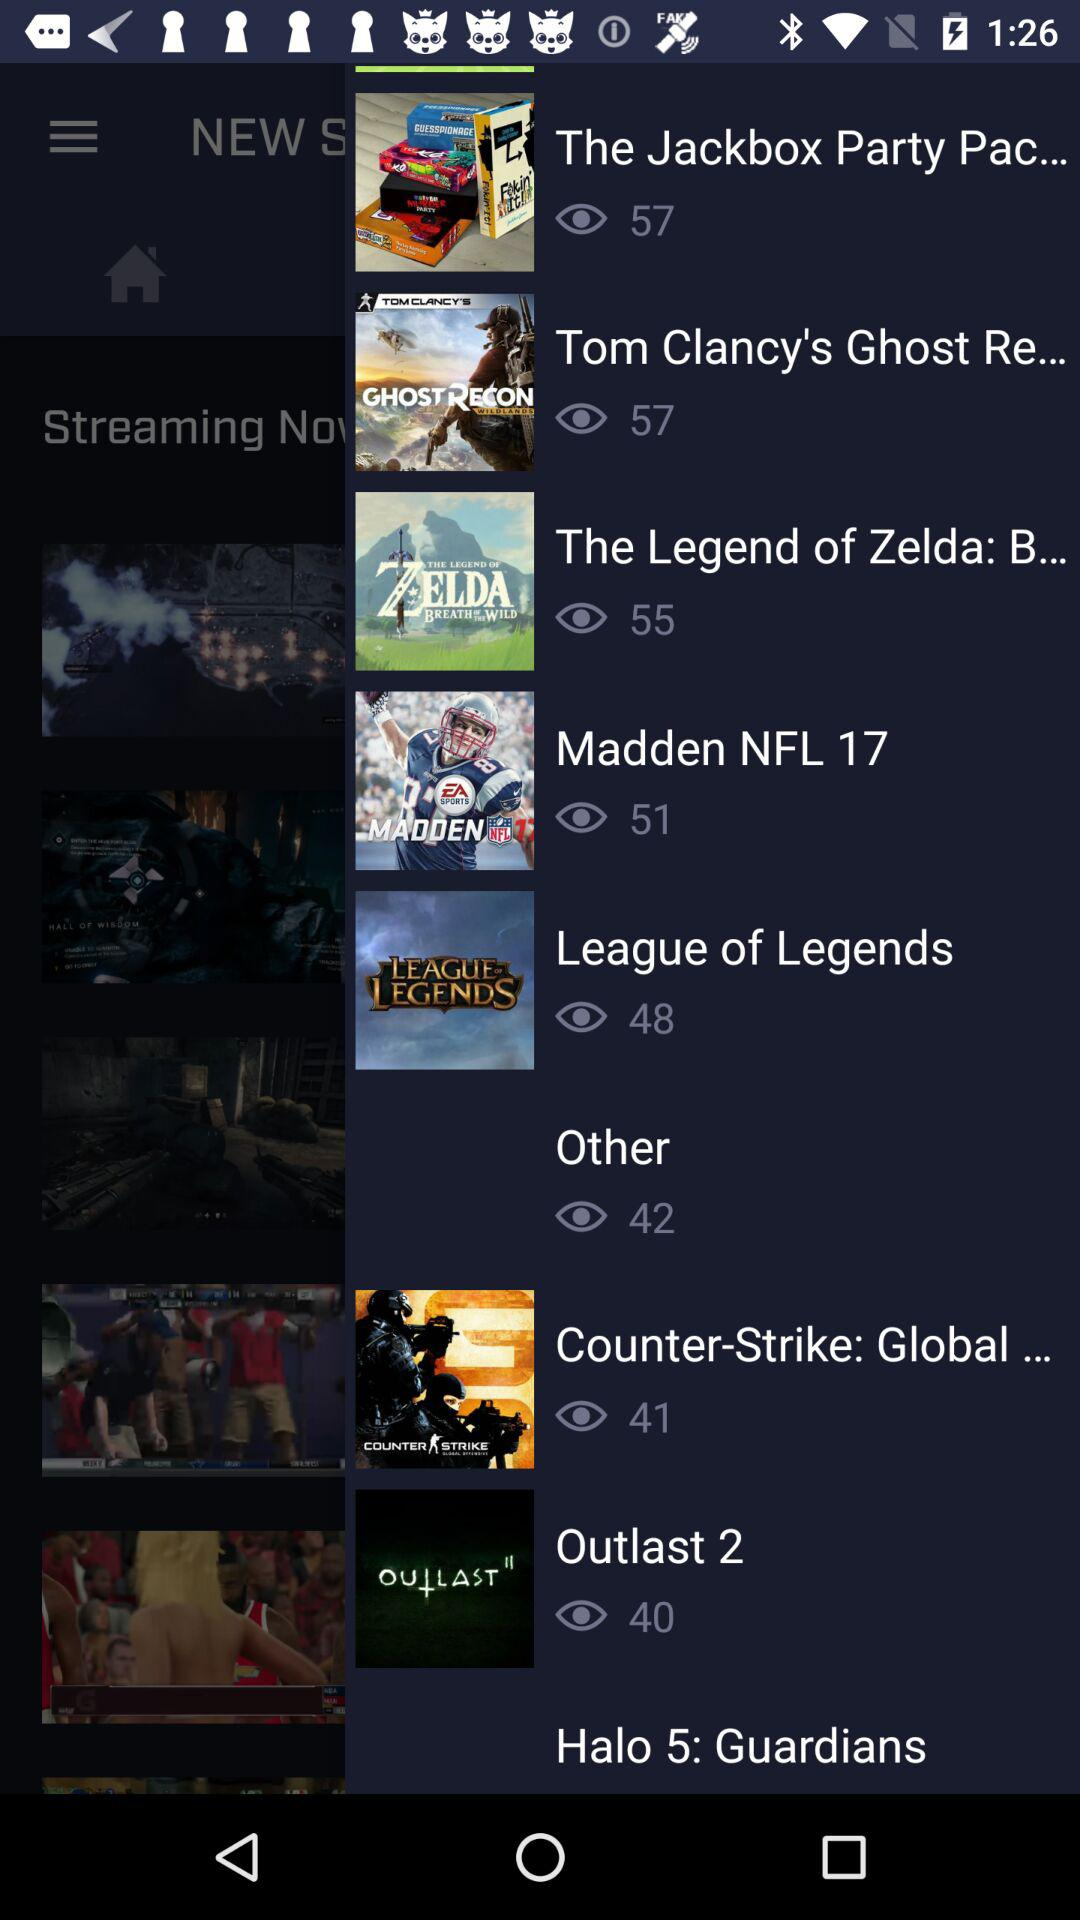How many views are there of "Madden NFL 17"? There are 51 views. 